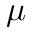Convert formula to latex. <formula><loc_0><loc_0><loc_500><loc_500>\mu</formula> 